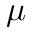Convert formula to latex. <formula><loc_0><loc_0><loc_500><loc_500>\mu</formula> 